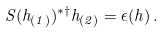<formula> <loc_0><loc_0><loc_500><loc_500>S ( h _ { ( 1 ) } ) ^ { * \dag } h _ { ( 2 ) } = \epsilon ( h ) \, .</formula> 